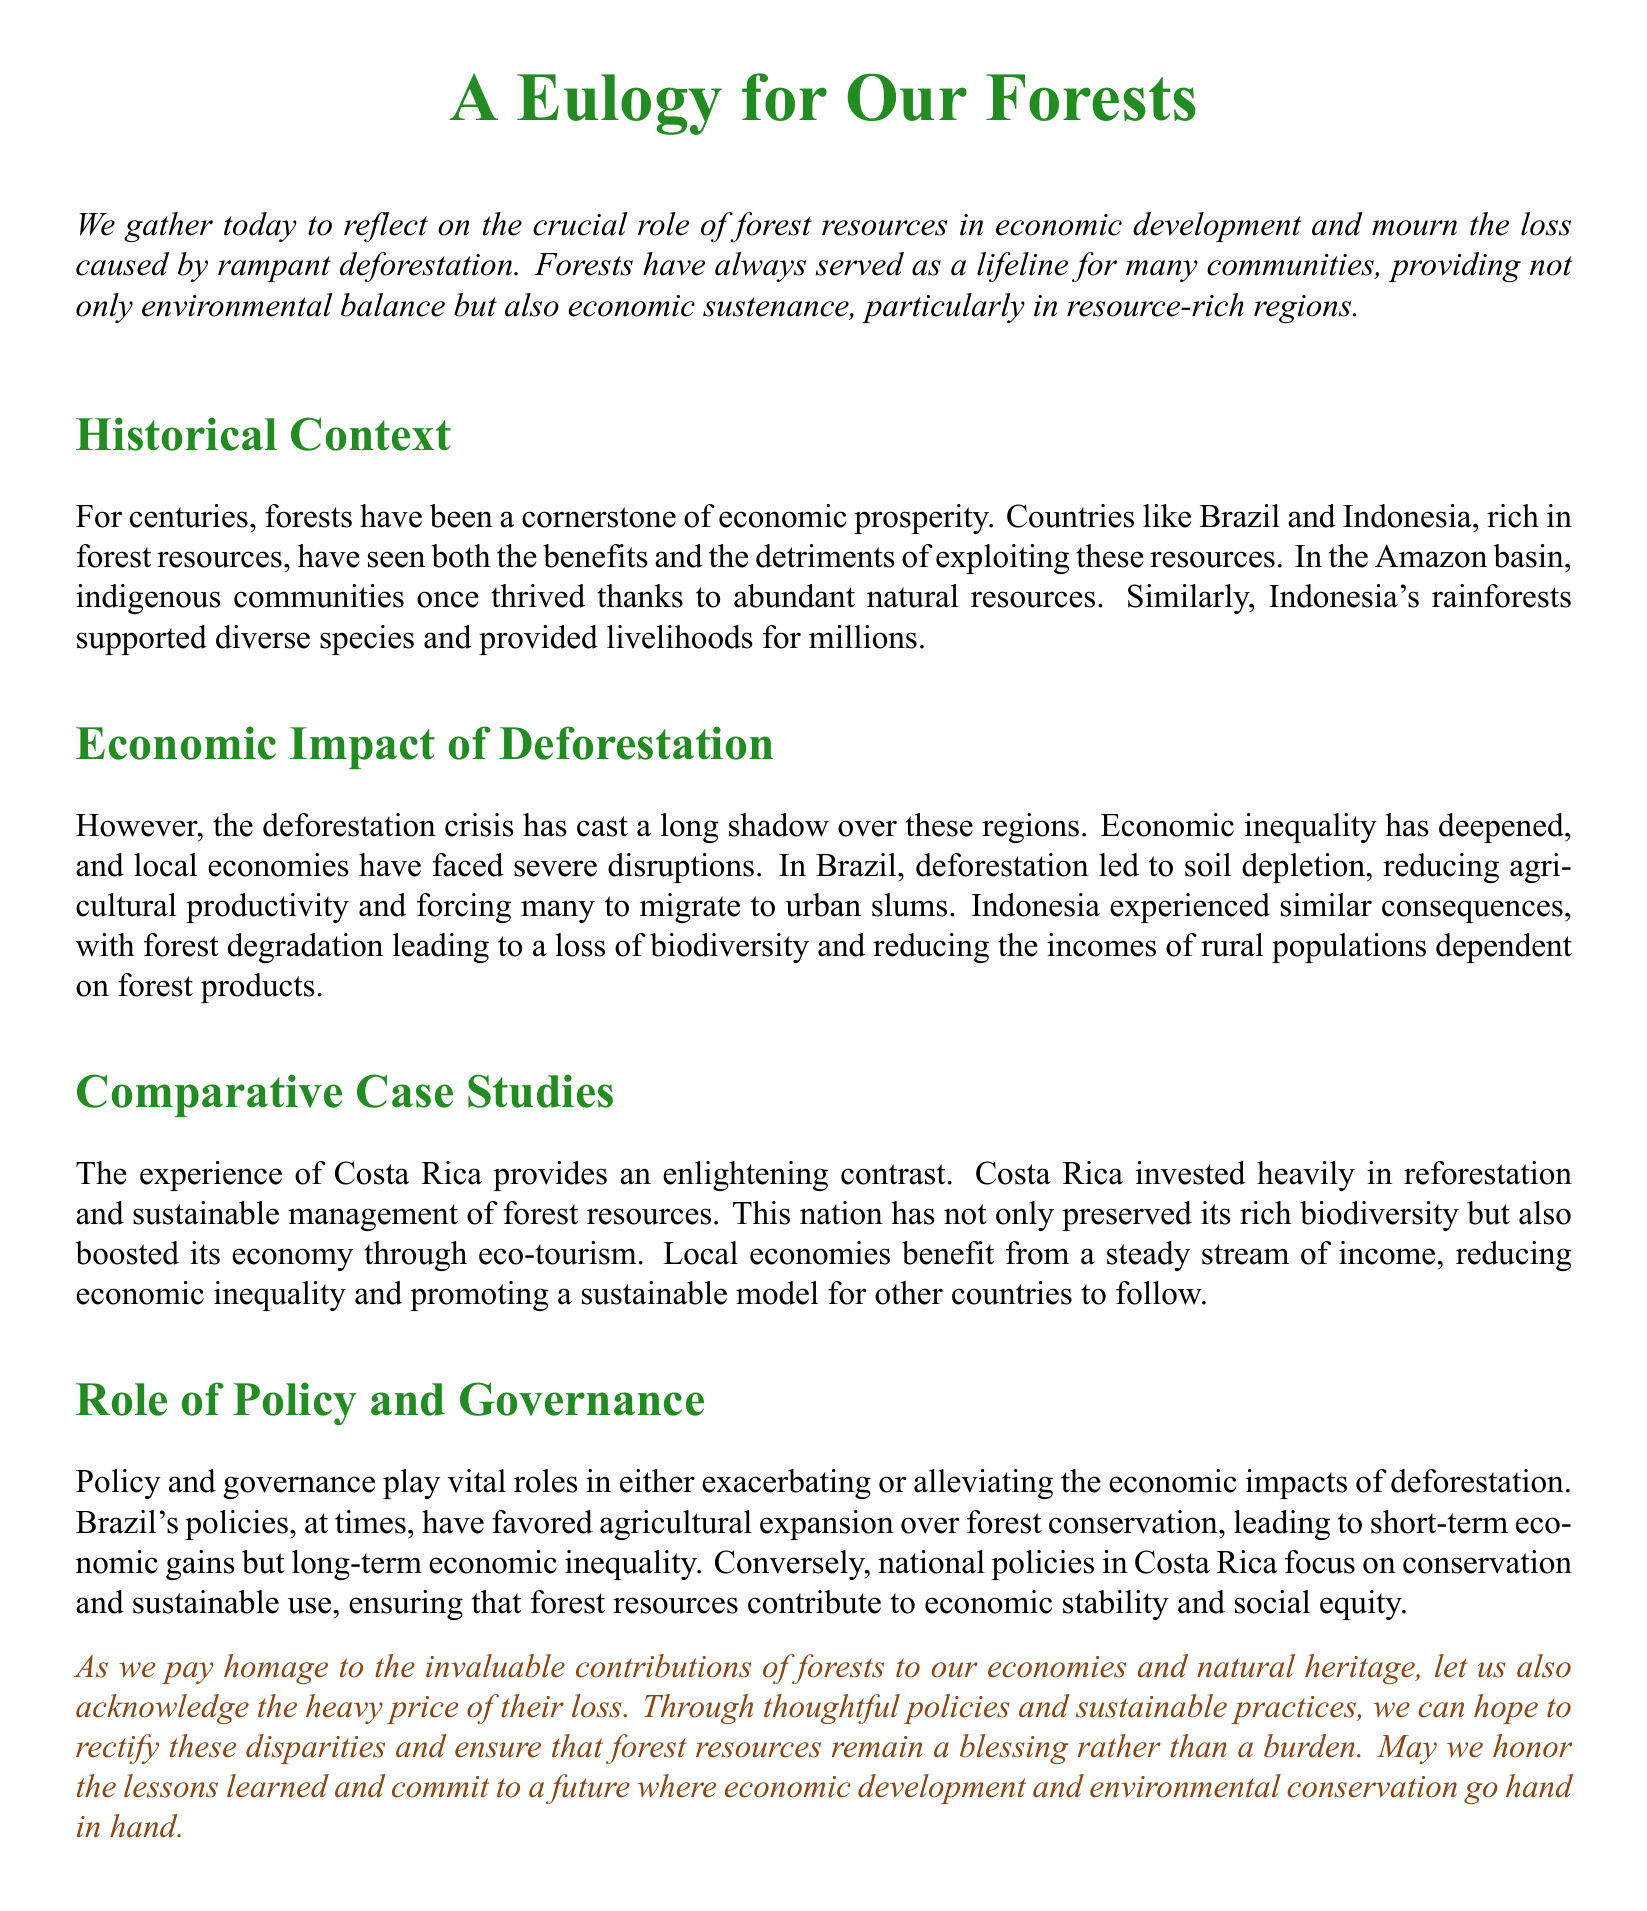What is the main subject of the document? The document centers around the importance of forests in economic development and the impact of deforestation.
Answer: forests Which countries are mentioned as examples of economic impact due to deforestation? Brazil and Indonesia are provided as examples of regions experiencing the repercussions of deforestation.
Answer: Brazil and Indonesia What positive economic outcome did Costa Rica achieve? Costa Rica saw economic benefits through eco-tourism due to its investment in reforestation and sustainable management.
Answer: eco-tourism What is the main negative effect of deforestation discussed in the document? The document highlights economic inequality as a significant negative consequence of deforestation.
Answer: economic inequality What does the document suggest as a key factor in mitigating the impacts of deforestation? Thoughtful policies and sustainable practices are suggested as essential for mitigating the adverse effects of deforestation.
Answer: thoughtful policies Which style of governance has caused economic inequality in Brazil? Policies favoring agricultural expansion rather than forest conservation have exacerbated economic inequality in Brazil.
Answer: agricultural expansion What is the overall message of the eulogy? The eulogy emphasizes the need for a balance between economic development and environmental conservation.
Answer: balance 